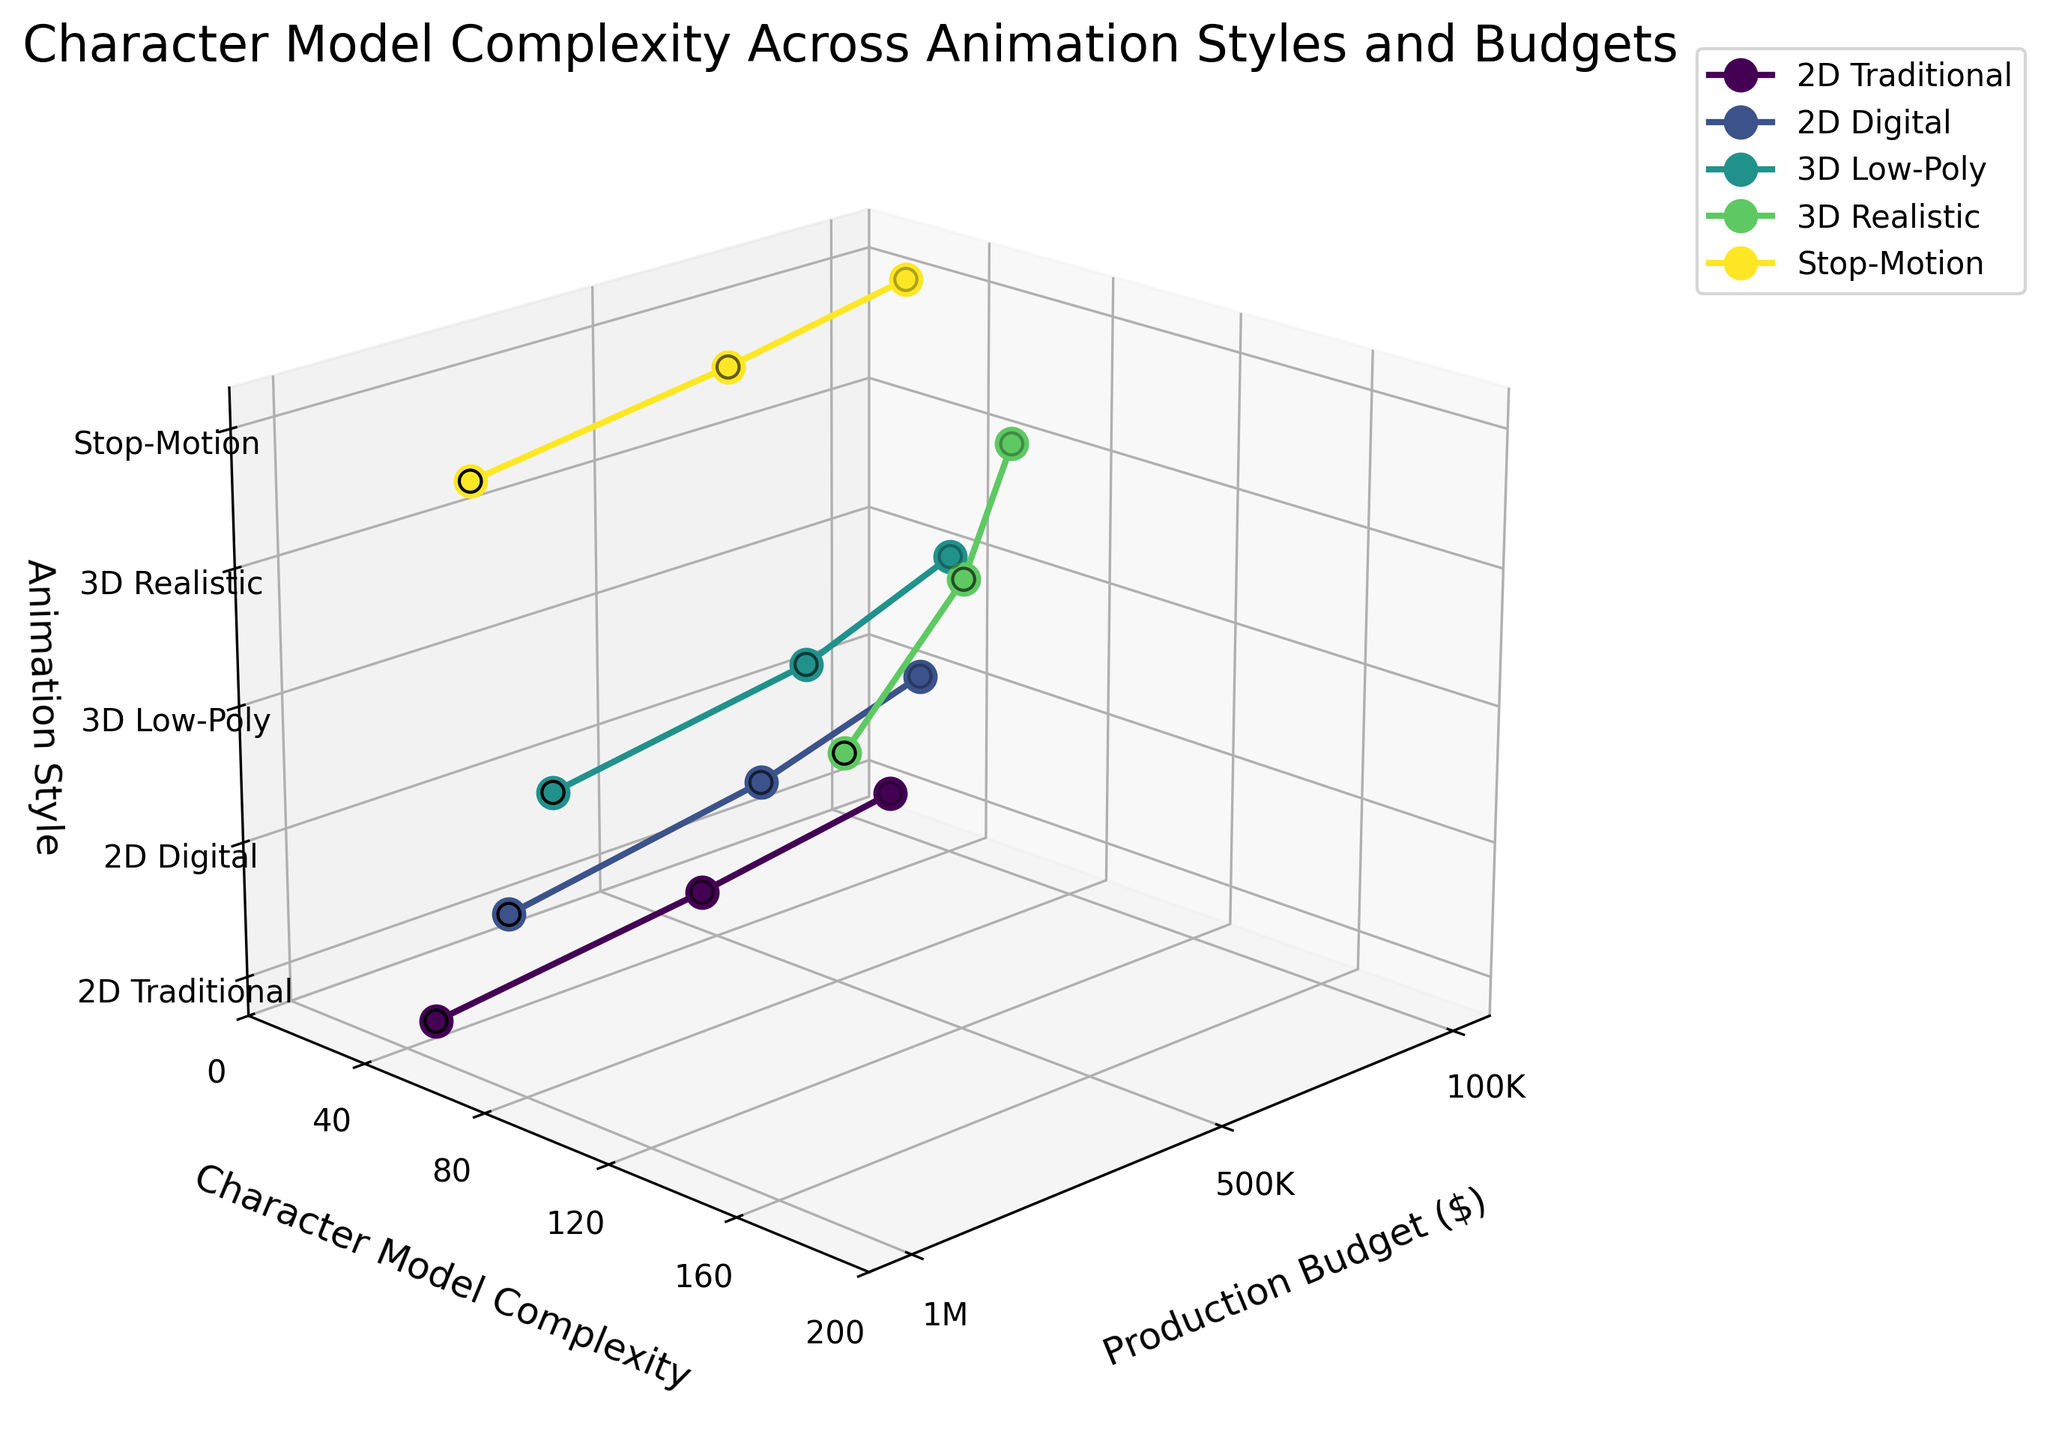What is the title of the plot? The title is found at the top of the plot. It describes the main focus of the data visualization.
Answer: Character Model Complexity Across Animation Styles and Budgets Which animation style has the highest range of character model complexity? To determine the highest range, observe the difference between the maximum and minimum values on the y-axis (Character Model Complexity) for each animation style. 3D Realistic has the highest range (from 60 to 180).
Answer: 3D Realistic How many animation styles are presented in the plot? Count the unique labels along the z-axis. Each tick label corresponds to a distinct animation style. There are five labels.
Answer: Five Which animation style has the lowest character model complexity at a $500,000 production budget? Find the data points corresponding to the $500,000 production budget along the x-axis, then check which of these has the lowest y-axis (Character Model Complexity) value. Stop-Motion has the lowest complexity at 45.
Answer: Stop-Motion What is the average character model complexity for 2D Traditional style? Identify the y-values for all points in the 2D Traditional category, then calculate their average: (20+35+50)/3 = 35.
Answer: 35 Which animation style shows the steepest increase in character model complexity with increasing production budget? Look at the slopes of the lines connecting the points for each style. 3D Realistic shows the steepest increase from 60 to 180.
Answer: 3D Realistic How does character model complexity for Stop-Motion animation at a $1,000,000 budget compare to 3D Low-Poly at a $500,000 budget? Find the y-values for Stop-Motion at $1,000,000 and 3D Low-Poly at $500,000, then compare them. Stop-Motion is at 65, while 3D Low-Poly is at 70, making 3D Low-Poly slightly higher.
Answer: 3D Low-Poly is higher Describe the relationship between production budget and character model complexity for 2D Digital style. Examine the plotted points for 2D Digital style and observe how the y-values change with increasing x-values. As the production budget increases from $100,000 to $1,000,000, character model complexity increases from 30 to 75.
Answer: Positive correlation: complexity increases with budget Which animation style has the least variation in character model complexity across different production budgets? Identify which style has the smallest spread (difference between maximum and minimum values) on the y-axis. 2D Traditional has the smallest variation, with values ranging from 20 to 50.
Answer: 2D Traditional 